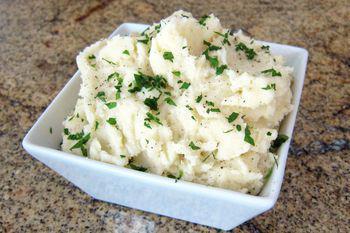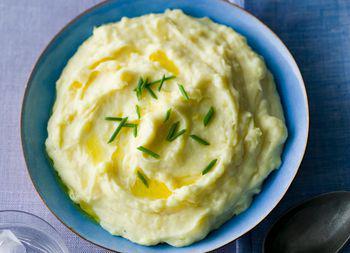The first image is the image on the left, the second image is the image on the right. For the images shown, is this caption "The potatoes in the image on the left are served in a square shaped bowl." true? Answer yes or no. Yes. The first image is the image on the left, the second image is the image on the right. Analyze the images presented: Is the assertion "Mashed potatoes are in a squared white dish in one image." valid? Answer yes or no. Yes. 